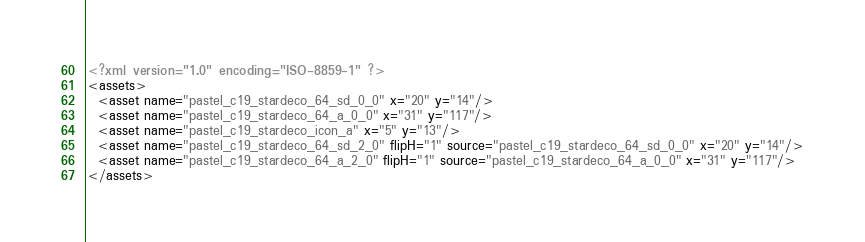Convert code to text. <code><loc_0><loc_0><loc_500><loc_500><_XML_><?xml version="1.0" encoding="ISO-8859-1" ?><assets>
  <asset name="pastel_c19_stardeco_64_sd_0_0" x="20" y="14"/>
  <asset name="pastel_c19_stardeco_64_a_0_0" x="31" y="117"/>
  <asset name="pastel_c19_stardeco_icon_a" x="5" y="13"/>
  <asset name="pastel_c19_stardeco_64_sd_2_0" flipH="1" source="pastel_c19_stardeco_64_sd_0_0" x="20" y="14"/>
  <asset name="pastel_c19_stardeco_64_a_2_0" flipH="1" source="pastel_c19_stardeco_64_a_0_0" x="31" y="117"/>
</assets></code> 